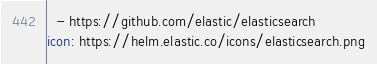Convert code to text. <code><loc_0><loc_0><loc_500><loc_500><_YAML_>  - https://github.com/elastic/elasticsearch
icon: https://helm.elastic.co/icons/elasticsearch.png
</code> 